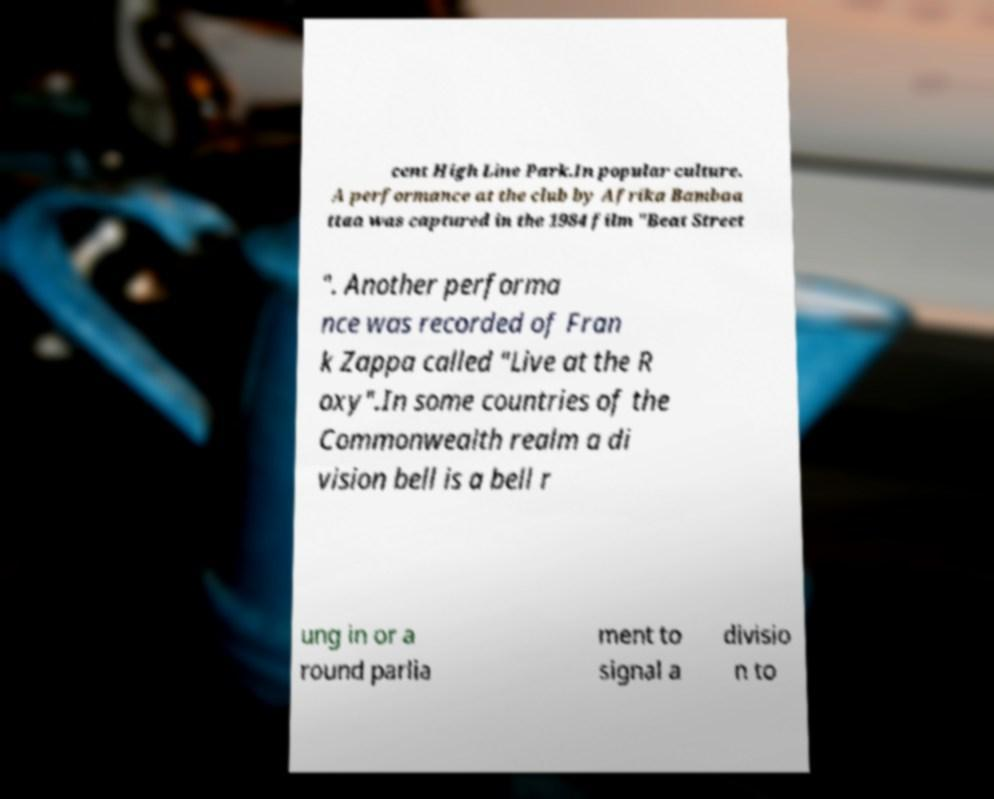Could you extract and type out the text from this image? cent High Line Park.In popular culture. A performance at the club by Afrika Bambaa ttaa was captured in the 1984 film "Beat Street ". Another performa nce was recorded of Fran k Zappa called "Live at the R oxy".In some countries of the Commonwealth realm a di vision bell is a bell r ung in or a round parlia ment to signal a divisio n to 